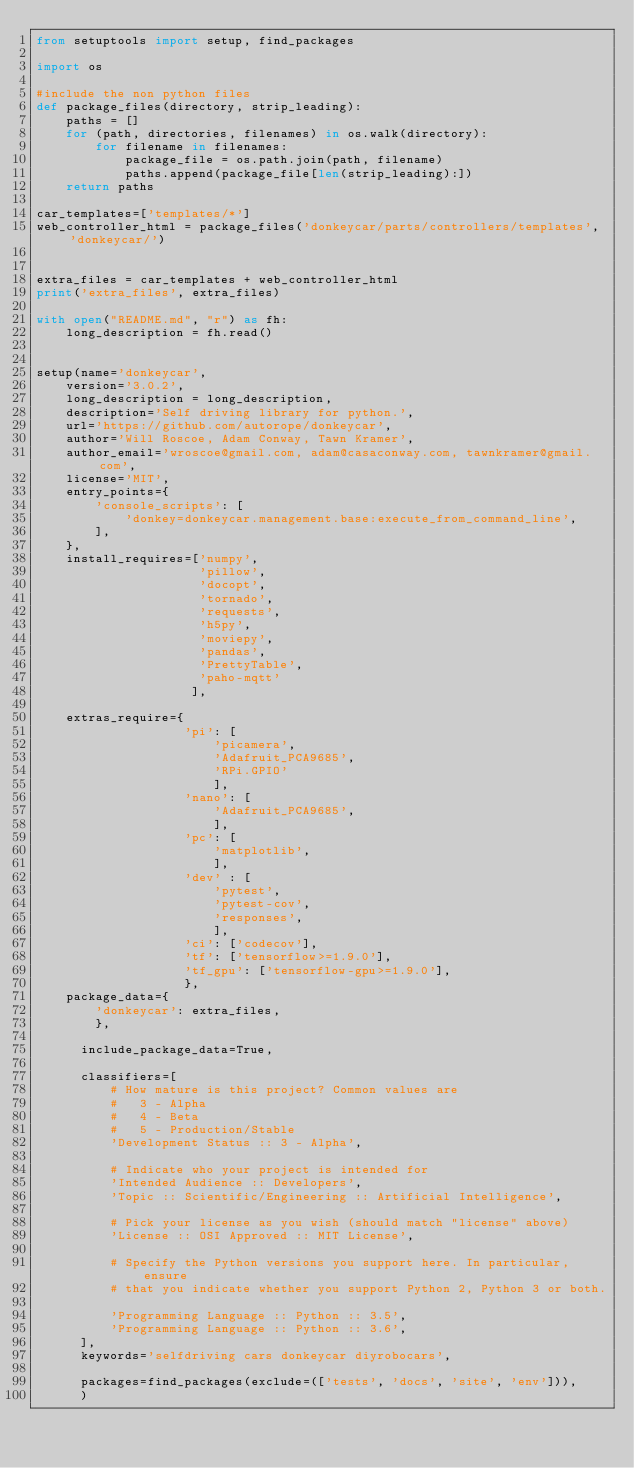<code> <loc_0><loc_0><loc_500><loc_500><_Python_>from setuptools import setup, find_packages

import os

#include the non python files
def package_files(directory, strip_leading):
    paths = []
    for (path, directories, filenames) in os.walk(directory):
        for filename in filenames:
            package_file = os.path.join(path, filename)
            paths.append(package_file[len(strip_leading):])
    return paths

car_templates=['templates/*']
web_controller_html = package_files('donkeycar/parts/controllers/templates', 'donkeycar/')


extra_files = car_templates + web_controller_html
print('extra_files', extra_files)

with open("README.md", "r") as fh:
    long_description = fh.read()


setup(name='donkeycar',
    version='3.0.2',
    long_description = long_description,
    description='Self driving library for python.',
    url='https://github.com/autorope/donkeycar',
    author='Will Roscoe, Adam Conway, Tawn Kramer',
    author_email='wroscoe@gmail.com, adam@casaconway.com, tawnkramer@gmail.com',
    license='MIT',
    entry_points={
        'console_scripts': [
            'donkey=donkeycar.management.base:execute_from_command_line',
        ],
    },
    install_requires=['numpy', 
                      'pillow',
                      'docopt',
                      'tornado',
                      'requests',
                      'h5py',
                      'moviepy',
                      'pandas',
                      'PrettyTable',
                      'paho-mqtt'
                     ],

    extras_require={
                    'pi': [
                        'picamera',
                        'Adafruit_PCA9685',
                        'RPi.GPIO'
                        ],
                    'nano': [
                        'Adafruit_PCA9685',                        
                        ],
                    'pc': [
                        'matplotlib',
                        ],
                    'dev' : [
                        'pytest',
                        'pytest-cov',
                        'responses',
                        ],
                    'ci': ['codecov'],
                    'tf': ['tensorflow>=1.9.0'],
                    'tf_gpu': ['tensorflow-gpu>=1.9.0'],
                    },
    package_data={
        'donkeycar': extra_files, 
        },

      include_package_data=True,

      classifiers=[
          # How mature is this project? Common values are
          #   3 - Alpha
          #   4 - Beta
          #   5 - Production/Stable
          'Development Status :: 3 - Alpha',

          # Indicate who your project is intended for
          'Intended Audience :: Developers',
          'Topic :: Scientific/Engineering :: Artificial Intelligence',

          # Pick your license as you wish (should match "license" above)
          'License :: OSI Approved :: MIT License',

          # Specify the Python versions you support here. In particular, ensure
          # that you indicate whether you support Python 2, Python 3 or both.

          'Programming Language :: Python :: 3.5',
          'Programming Language :: Python :: 3.6',
      ],
      keywords='selfdriving cars donkeycar diyrobocars',

      packages=find_packages(exclude=(['tests', 'docs', 'site', 'env'])),
      )
</code> 